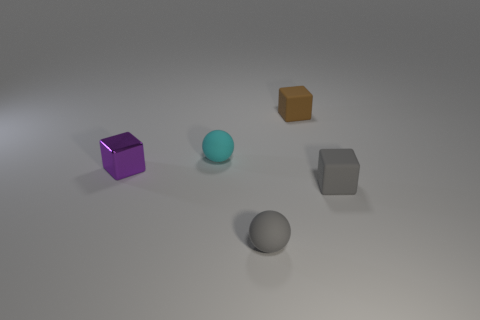Do the brown object and the purple thing have the same shape?
Your answer should be compact. Yes. What material is the sphere that is in front of the gray rubber object right of the thing that is behind the small cyan object made of?
Keep it short and to the point. Rubber. What number of rubber things are tiny blue cubes or balls?
Your response must be concise. 2. What number of yellow objects are tiny metal objects or tiny spheres?
Provide a succinct answer. 0. Is the color of the rubber block behind the small purple object the same as the small shiny block?
Offer a terse response. No. Does the gray cube have the same material as the cyan thing?
Offer a very short reply. Yes. Are there the same number of matte cubes that are in front of the metal block and tiny purple shiny objects that are on the left side of the brown rubber object?
Give a very brief answer. Yes. There is a gray thing that is the same shape as the brown rubber object; what is its material?
Make the answer very short. Rubber. There is a small matte thing that is on the left side of the matte object that is in front of the rubber block in front of the small metal block; what is its shape?
Offer a very short reply. Sphere. Is the number of small things on the right side of the small cyan sphere greater than the number of large red rubber balls?
Offer a terse response. Yes. 